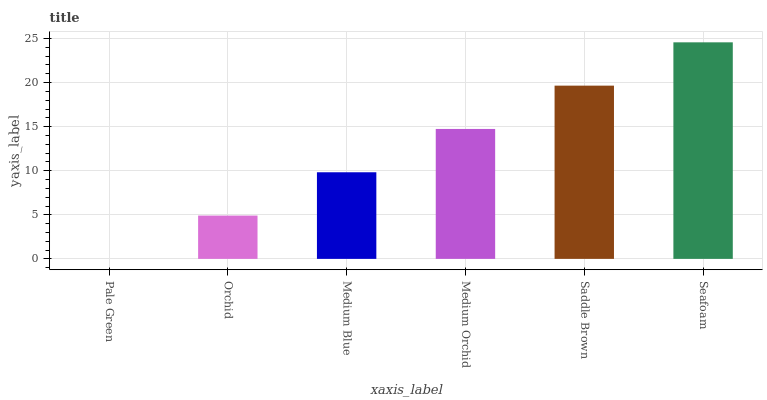Is Pale Green the minimum?
Answer yes or no. Yes. Is Seafoam the maximum?
Answer yes or no. Yes. Is Orchid the minimum?
Answer yes or no. No. Is Orchid the maximum?
Answer yes or no. No. Is Orchid greater than Pale Green?
Answer yes or no. Yes. Is Pale Green less than Orchid?
Answer yes or no. Yes. Is Pale Green greater than Orchid?
Answer yes or no. No. Is Orchid less than Pale Green?
Answer yes or no. No. Is Medium Orchid the high median?
Answer yes or no. Yes. Is Medium Blue the low median?
Answer yes or no. Yes. Is Saddle Brown the high median?
Answer yes or no. No. Is Orchid the low median?
Answer yes or no. No. 